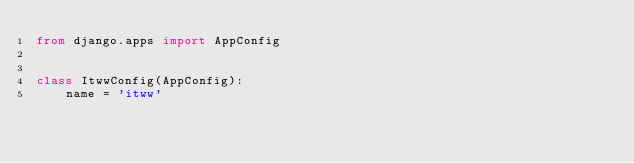<code> <loc_0><loc_0><loc_500><loc_500><_Python_>from django.apps import AppConfig


class ItwwConfig(AppConfig):
    name = 'itww'
</code> 